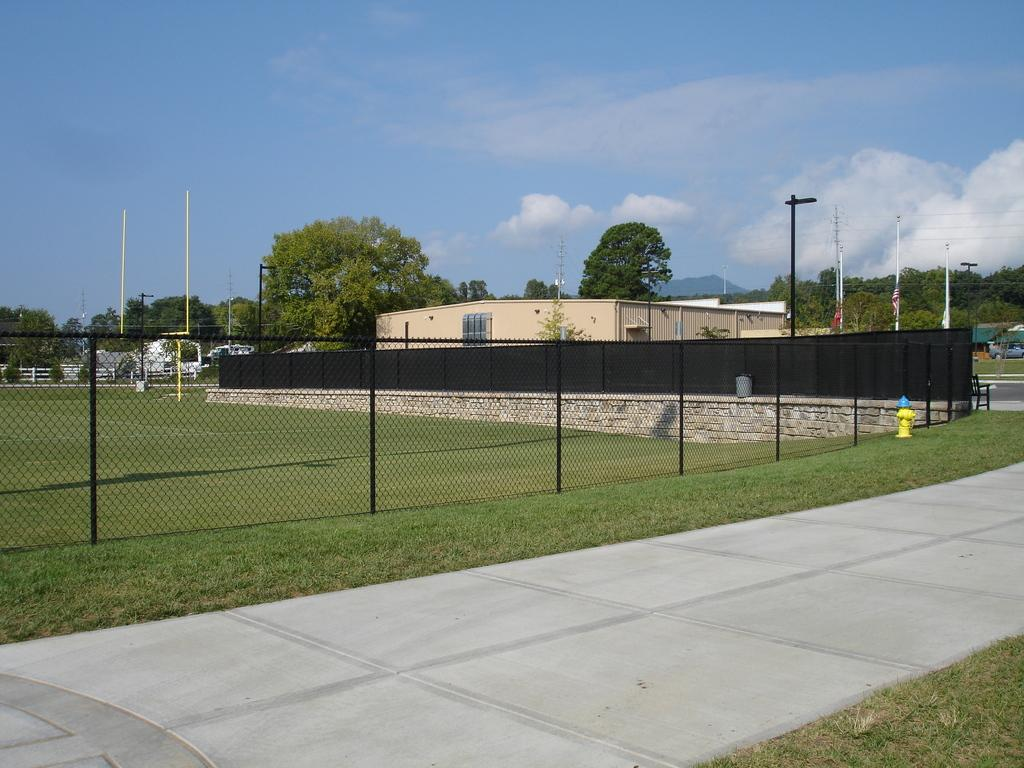What type of structure can be seen in the image? There is a fence and a house in the image. What other objects can be seen in the image? There are trees, a pole, a fire hydrant, and a pathway in the image. What is present at the bottom of the image? There is a pathway and grass at the bottom of the image. What can be seen in the background of the image? The sky is visible in the background of the image. How many rings are visible on the fire hydrant in the image? There are no rings visible on the fire hydrant in the image. What type of wound can be seen on the tree in the image? There are no wounds visible on the trees in the image. 